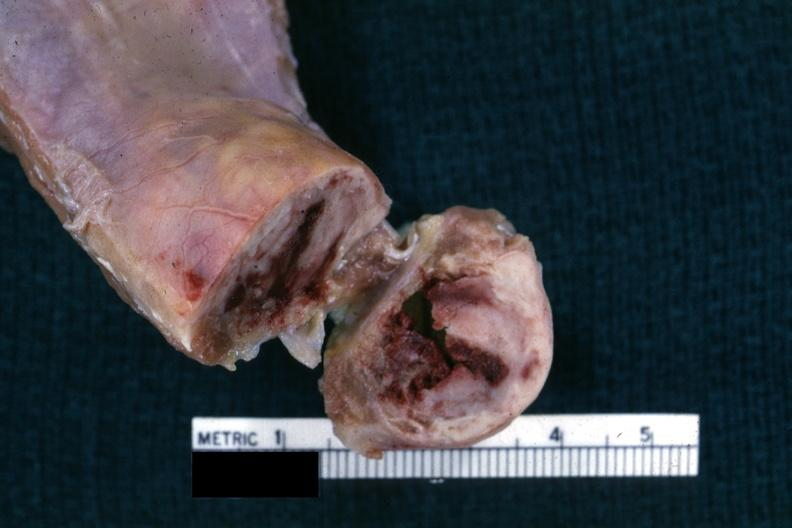does this image show close-up view of cross sectioned rib lesion showing white neoplastic lesion with hemorrhagic center?
Answer the question using a single word or phrase. Yes 